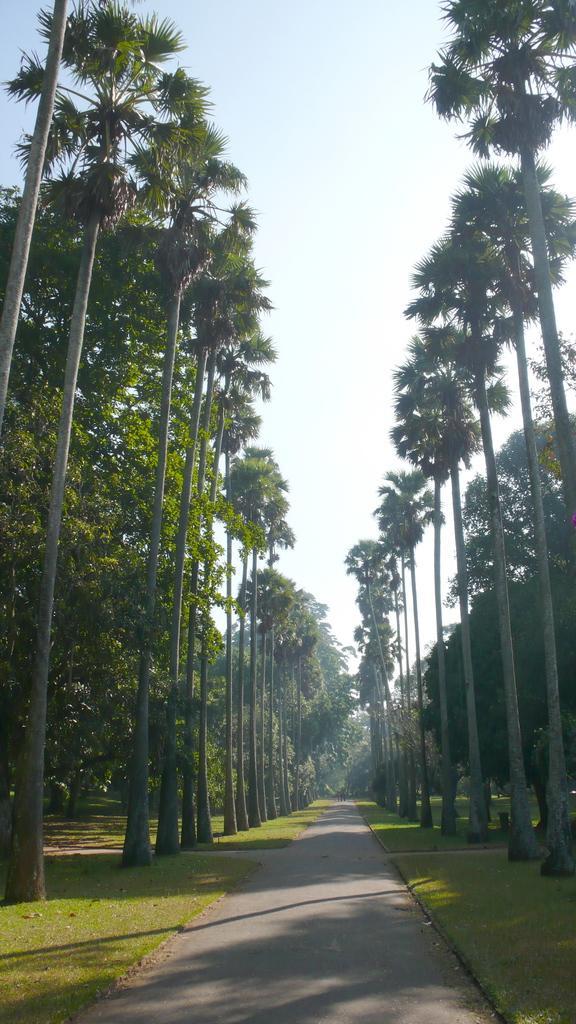Please provide a concise description of this image. In this image we can see trees, ground, road and sky. 